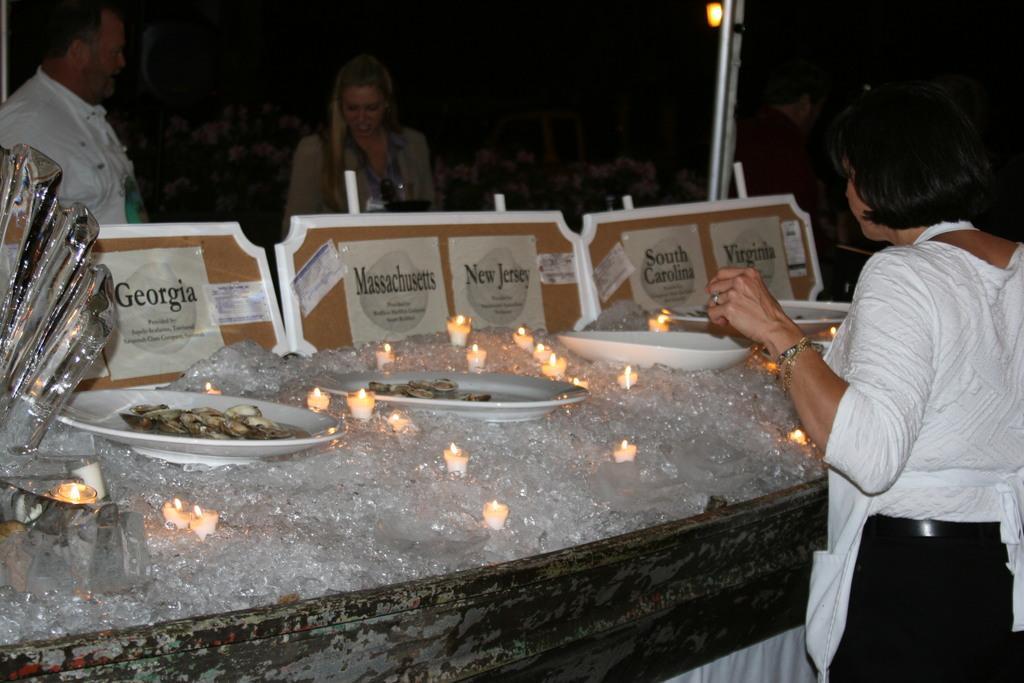Describe this image in one or two sentences. There are three people standing. This looks like the ice cubes. I can see the candles and plates with food are placed on the ice cubes. These are the boards. On the left side of the image, that looks like an object. This is a pole. 